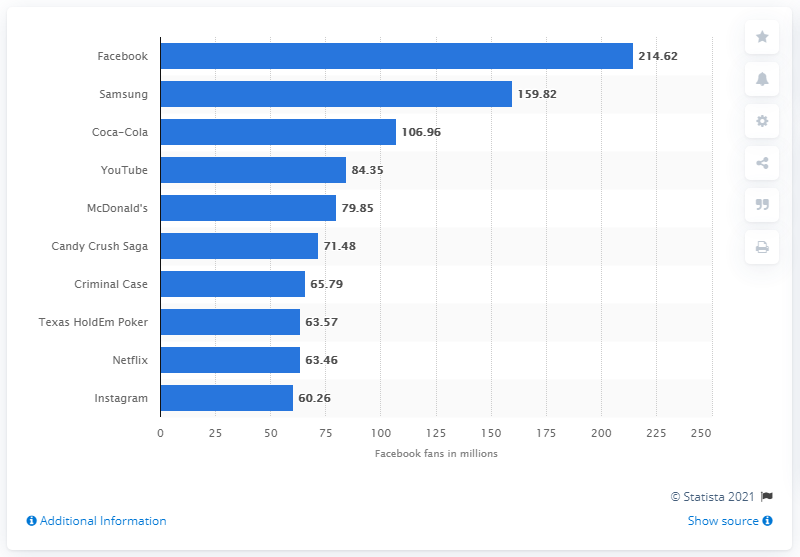Draw attention to some important aspects in this diagram. As of November 2021, Coca-Cola has 106.96 million Facebook followers. 